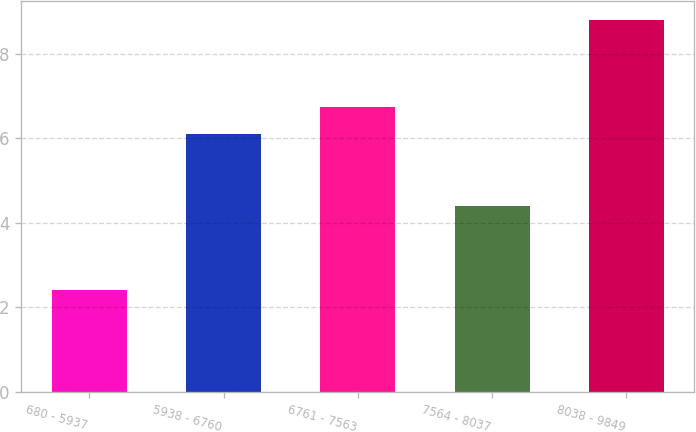Convert chart. <chart><loc_0><loc_0><loc_500><loc_500><bar_chart><fcel>680 - 5937<fcel>5938 - 6760<fcel>6761 - 7563<fcel>7564 - 8037<fcel>8038 - 9849<nl><fcel>2.4<fcel>6.1<fcel>6.74<fcel>4.4<fcel>8.8<nl></chart> 